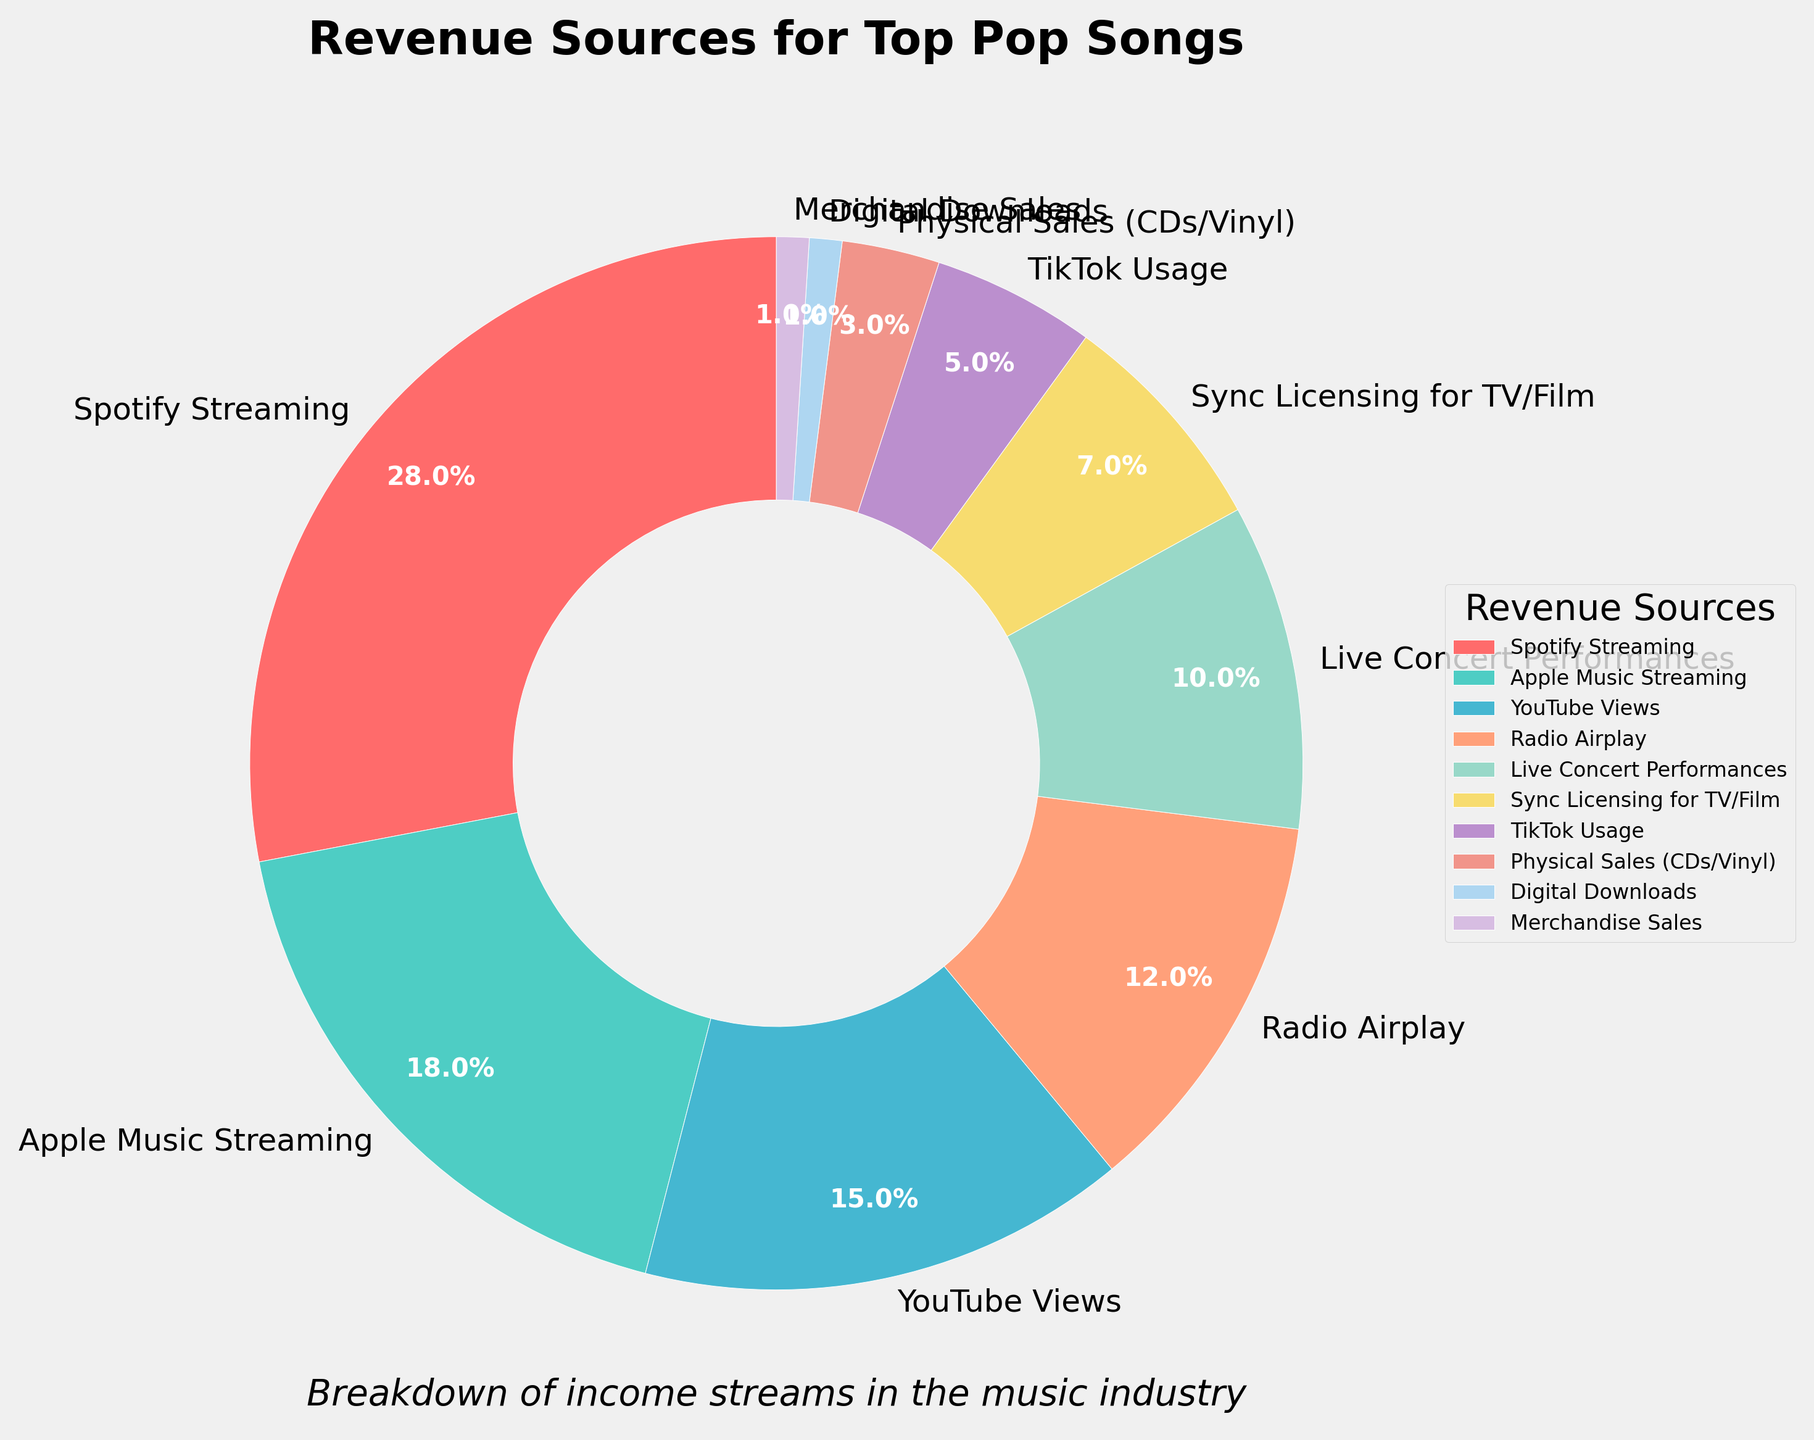What is the largest revenue source for top pop songs? Looking at the size of the wedges in the pie chart, the largest revenue source can be identified. The "Spotify Streaming" wedge is the largest.
Answer: Spotify Streaming What percentage of revenue comes from Live Concert Performances and Merchandise Sales combined? Locate the slices for "Live Concert Performances" and "Merchandise Sales" and sum their percentages. Live Concert Performances contribute 10% and Merchandise Sales contribute 1%, making the total 10% + 1% = 11%.
Answer: 11% Which revenue source contributes more: Apple Music Streaming or YouTube Views? Compare the sizes of the "Apple Music Streaming" and "YouTube Views" wedges. Apple Music Streaming is labeled as 18% and YouTube Views as 15%. Therefore, Apple Music Streaming contributes more.
Answer: Apple Music Streaming How much more percentage does Spotify Streaming bring in compared to Radio Airplay? Identify the percentages for Spotify Streaming (28%) and Radio Airplay (12%). Calculate the difference: 28% - 12% = 16%.
Answer: 16% What is the combined percentage of all streaming-related revenue sources? Identify and sum the percentages of all streaming-related categories: Spotify Streaming (28%), Apple Music Streaming (18%), and YouTube Views (15%). 28% + 18% + 15% = 61%.
Answer: 61% If TikTok Usage and Physical Sales (CDs/Vinyl) were combined into one category, what would be its percentage? Sum the percentages for TikTok Usage and Physical Sales (CDs/Vinyl). TikTok Usage is 5% and Physical Sales (CDs/Vinyl) is 3%, so 5% + 3% = 8%.
Answer: 8% Which revenue sources make up exactly one-third of the total revenue? Identify the sources and their percentages such that their sum equals one-third (33.33%). Apple Music Streaming (18%) and YouTube Views (15%) together sum to 18% + 15% = 33%.
Answer: Apple Music Streaming and YouTube Views Which source of revenue is higher: Sync Licensing for TV/Film or TikTok Usage? Compare the sizes of the "Sync Licensing for TV/Film" and "TikTok Usage" wedges. Sync Licensing for TV/Film is 7% and TikTok Usage is 5%. Therefore, Sync Licensing for TV/Film is higher.
Answer: Sync Licensing for TV/Film What is the combined revenue percentage for all non-streaming sources? Sum the percentages of all non-streaming revenue sources: Radio Airplay (12%), Live Concert Performances (10%), Sync Licensing for TV/Film (7%), TikTok Usage (5%), Physical Sales (CDs/Vinyl) (3%), Digital Downloads (1%), and Merchandise Sales (1%). The total is 12% + 10% + 7% + 5% + 3% + 1% + 1% = 39%.
Answer: 39% Which category has the smallest percentage, and what is that percentage? Identify the smallest wedge in the pie chart. Digital Downloads and Merchandise Sales both have the smallest percentage at 1%.
Answer: Digital Downloads and Merchandise Sales (1%) 